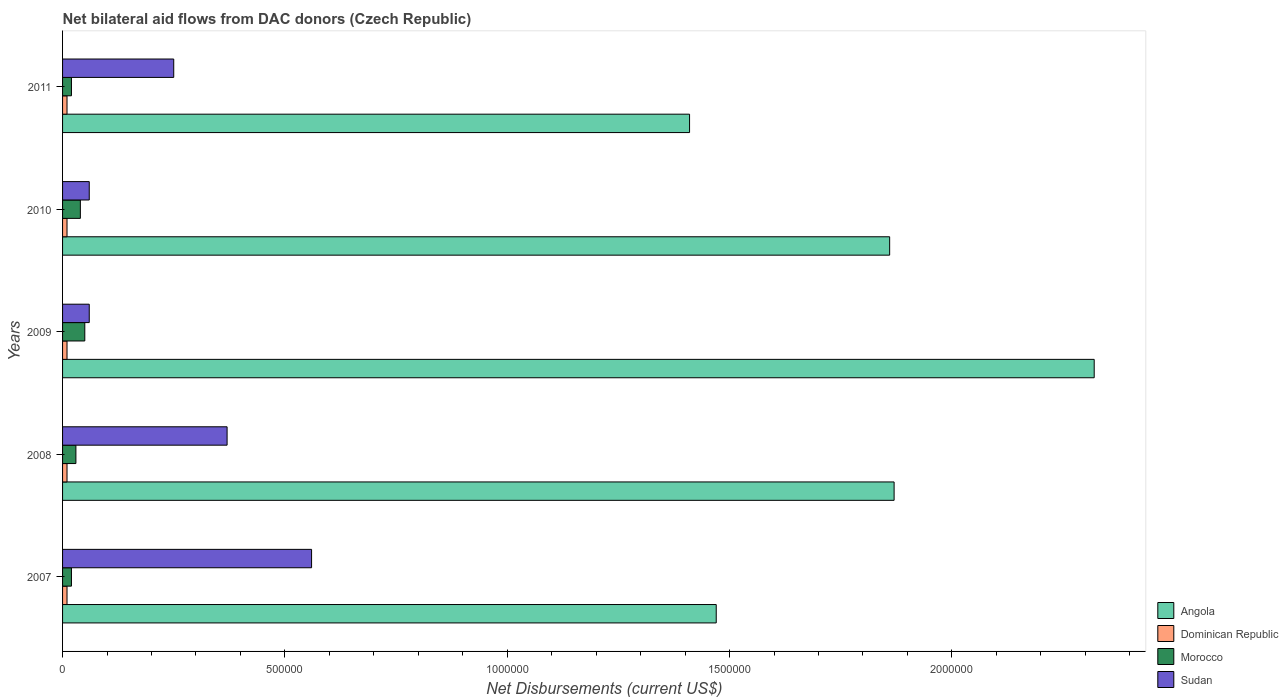How many different coloured bars are there?
Your response must be concise. 4. How many groups of bars are there?
Offer a very short reply. 5. Are the number of bars on each tick of the Y-axis equal?
Your answer should be compact. Yes. How many bars are there on the 1st tick from the bottom?
Offer a very short reply. 4. What is the label of the 3rd group of bars from the top?
Your answer should be very brief. 2009. In how many cases, is the number of bars for a given year not equal to the number of legend labels?
Make the answer very short. 0. What is the net bilateral aid flows in Angola in 2008?
Make the answer very short. 1.87e+06. Across all years, what is the maximum net bilateral aid flows in Sudan?
Your answer should be very brief. 5.60e+05. In which year was the net bilateral aid flows in Morocco minimum?
Offer a terse response. 2007. What is the total net bilateral aid flows in Angola in the graph?
Offer a very short reply. 8.93e+06. What is the difference between the net bilateral aid flows in Sudan in 2007 and that in 2009?
Make the answer very short. 5.00e+05. What is the difference between the net bilateral aid flows in Angola in 2009 and the net bilateral aid flows in Sudan in 2011?
Keep it short and to the point. 2.07e+06. What is the average net bilateral aid flows in Dominican Republic per year?
Offer a terse response. 10000. In the year 2007, what is the difference between the net bilateral aid flows in Dominican Republic and net bilateral aid flows in Sudan?
Provide a succinct answer. -5.50e+05. In how many years, is the net bilateral aid flows in Sudan greater than 200000 US$?
Make the answer very short. 3. What is the ratio of the net bilateral aid flows in Dominican Republic in 2009 to that in 2010?
Provide a succinct answer. 1. Is the net bilateral aid flows in Dominican Republic in 2008 less than that in 2009?
Your response must be concise. No. What is the difference between the highest and the second highest net bilateral aid flows in Morocco?
Your answer should be compact. 10000. What is the difference between the highest and the lowest net bilateral aid flows in Angola?
Make the answer very short. 9.10e+05. What does the 4th bar from the top in 2011 represents?
Provide a short and direct response. Angola. What does the 1st bar from the bottom in 2008 represents?
Provide a succinct answer. Angola. Is it the case that in every year, the sum of the net bilateral aid flows in Angola and net bilateral aid flows in Sudan is greater than the net bilateral aid flows in Dominican Republic?
Give a very brief answer. Yes. How many bars are there?
Give a very brief answer. 20. Are all the bars in the graph horizontal?
Give a very brief answer. Yes. Are the values on the major ticks of X-axis written in scientific E-notation?
Provide a succinct answer. No. Does the graph contain any zero values?
Your response must be concise. No. Where does the legend appear in the graph?
Make the answer very short. Bottom right. How are the legend labels stacked?
Your answer should be compact. Vertical. What is the title of the graph?
Your answer should be very brief. Net bilateral aid flows from DAC donors (Czech Republic). Does "Greece" appear as one of the legend labels in the graph?
Your answer should be very brief. No. What is the label or title of the X-axis?
Your answer should be very brief. Net Disbursements (current US$). What is the label or title of the Y-axis?
Offer a terse response. Years. What is the Net Disbursements (current US$) in Angola in 2007?
Your answer should be compact. 1.47e+06. What is the Net Disbursements (current US$) of Morocco in 2007?
Your answer should be compact. 2.00e+04. What is the Net Disbursements (current US$) in Sudan in 2007?
Your answer should be very brief. 5.60e+05. What is the Net Disbursements (current US$) in Angola in 2008?
Give a very brief answer. 1.87e+06. What is the Net Disbursements (current US$) of Dominican Republic in 2008?
Your response must be concise. 10000. What is the Net Disbursements (current US$) in Morocco in 2008?
Your answer should be compact. 3.00e+04. What is the Net Disbursements (current US$) in Angola in 2009?
Your response must be concise. 2.32e+06. What is the Net Disbursements (current US$) of Morocco in 2009?
Keep it short and to the point. 5.00e+04. What is the Net Disbursements (current US$) in Angola in 2010?
Ensure brevity in your answer.  1.86e+06. What is the Net Disbursements (current US$) of Dominican Republic in 2010?
Your response must be concise. 10000. What is the Net Disbursements (current US$) in Morocco in 2010?
Keep it short and to the point. 4.00e+04. What is the Net Disbursements (current US$) of Sudan in 2010?
Offer a very short reply. 6.00e+04. What is the Net Disbursements (current US$) in Angola in 2011?
Ensure brevity in your answer.  1.41e+06. What is the Net Disbursements (current US$) of Sudan in 2011?
Ensure brevity in your answer.  2.50e+05. Across all years, what is the maximum Net Disbursements (current US$) of Angola?
Make the answer very short. 2.32e+06. Across all years, what is the maximum Net Disbursements (current US$) of Dominican Republic?
Offer a terse response. 10000. Across all years, what is the maximum Net Disbursements (current US$) in Sudan?
Your answer should be very brief. 5.60e+05. Across all years, what is the minimum Net Disbursements (current US$) of Angola?
Offer a terse response. 1.41e+06. Across all years, what is the minimum Net Disbursements (current US$) of Dominican Republic?
Your response must be concise. 10000. Across all years, what is the minimum Net Disbursements (current US$) in Morocco?
Provide a succinct answer. 2.00e+04. Across all years, what is the minimum Net Disbursements (current US$) of Sudan?
Offer a terse response. 6.00e+04. What is the total Net Disbursements (current US$) of Angola in the graph?
Provide a short and direct response. 8.93e+06. What is the total Net Disbursements (current US$) of Sudan in the graph?
Provide a short and direct response. 1.30e+06. What is the difference between the Net Disbursements (current US$) in Angola in 2007 and that in 2008?
Give a very brief answer. -4.00e+05. What is the difference between the Net Disbursements (current US$) of Dominican Republic in 2007 and that in 2008?
Provide a succinct answer. 0. What is the difference between the Net Disbursements (current US$) of Sudan in 2007 and that in 2008?
Offer a very short reply. 1.90e+05. What is the difference between the Net Disbursements (current US$) in Angola in 2007 and that in 2009?
Provide a short and direct response. -8.50e+05. What is the difference between the Net Disbursements (current US$) in Sudan in 2007 and that in 2009?
Your answer should be very brief. 5.00e+05. What is the difference between the Net Disbursements (current US$) in Angola in 2007 and that in 2010?
Ensure brevity in your answer.  -3.90e+05. What is the difference between the Net Disbursements (current US$) of Dominican Republic in 2007 and that in 2010?
Your answer should be very brief. 0. What is the difference between the Net Disbursements (current US$) in Morocco in 2007 and that in 2010?
Provide a succinct answer. -2.00e+04. What is the difference between the Net Disbursements (current US$) of Sudan in 2007 and that in 2010?
Keep it short and to the point. 5.00e+05. What is the difference between the Net Disbursements (current US$) in Morocco in 2007 and that in 2011?
Provide a succinct answer. 0. What is the difference between the Net Disbursements (current US$) of Sudan in 2007 and that in 2011?
Make the answer very short. 3.10e+05. What is the difference between the Net Disbursements (current US$) in Angola in 2008 and that in 2009?
Provide a short and direct response. -4.50e+05. What is the difference between the Net Disbursements (current US$) in Morocco in 2008 and that in 2009?
Offer a very short reply. -2.00e+04. What is the difference between the Net Disbursements (current US$) of Morocco in 2009 and that in 2010?
Provide a short and direct response. 10000. What is the difference between the Net Disbursements (current US$) of Sudan in 2009 and that in 2010?
Provide a short and direct response. 0. What is the difference between the Net Disbursements (current US$) of Angola in 2009 and that in 2011?
Offer a terse response. 9.10e+05. What is the difference between the Net Disbursements (current US$) in Dominican Republic in 2009 and that in 2011?
Offer a very short reply. 0. What is the difference between the Net Disbursements (current US$) of Dominican Republic in 2010 and that in 2011?
Your answer should be compact. 0. What is the difference between the Net Disbursements (current US$) of Morocco in 2010 and that in 2011?
Keep it short and to the point. 2.00e+04. What is the difference between the Net Disbursements (current US$) of Sudan in 2010 and that in 2011?
Give a very brief answer. -1.90e+05. What is the difference between the Net Disbursements (current US$) in Angola in 2007 and the Net Disbursements (current US$) in Dominican Republic in 2008?
Keep it short and to the point. 1.46e+06. What is the difference between the Net Disbursements (current US$) in Angola in 2007 and the Net Disbursements (current US$) in Morocco in 2008?
Offer a very short reply. 1.44e+06. What is the difference between the Net Disbursements (current US$) in Angola in 2007 and the Net Disbursements (current US$) in Sudan in 2008?
Make the answer very short. 1.10e+06. What is the difference between the Net Disbursements (current US$) of Dominican Republic in 2007 and the Net Disbursements (current US$) of Sudan in 2008?
Your answer should be very brief. -3.60e+05. What is the difference between the Net Disbursements (current US$) in Morocco in 2007 and the Net Disbursements (current US$) in Sudan in 2008?
Your response must be concise. -3.50e+05. What is the difference between the Net Disbursements (current US$) of Angola in 2007 and the Net Disbursements (current US$) of Dominican Republic in 2009?
Provide a succinct answer. 1.46e+06. What is the difference between the Net Disbursements (current US$) of Angola in 2007 and the Net Disbursements (current US$) of Morocco in 2009?
Offer a terse response. 1.42e+06. What is the difference between the Net Disbursements (current US$) in Angola in 2007 and the Net Disbursements (current US$) in Sudan in 2009?
Offer a very short reply. 1.41e+06. What is the difference between the Net Disbursements (current US$) of Dominican Republic in 2007 and the Net Disbursements (current US$) of Sudan in 2009?
Make the answer very short. -5.00e+04. What is the difference between the Net Disbursements (current US$) of Angola in 2007 and the Net Disbursements (current US$) of Dominican Republic in 2010?
Provide a short and direct response. 1.46e+06. What is the difference between the Net Disbursements (current US$) of Angola in 2007 and the Net Disbursements (current US$) of Morocco in 2010?
Provide a succinct answer. 1.43e+06. What is the difference between the Net Disbursements (current US$) of Angola in 2007 and the Net Disbursements (current US$) of Sudan in 2010?
Provide a succinct answer. 1.41e+06. What is the difference between the Net Disbursements (current US$) in Angola in 2007 and the Net Disbursements (current US$) in Dominican Republic in 2011?
Make the answer very short. 1.46e+06. What is the difference between the Net Disbursements (current US$) in Angola in 2007 and the Net Disbursements (current US$) in Morocco in 2011?
Ensure brevity in your answer.  1.45e+06. What is the difference between the Net Disbursements (current US$) of Angola in 2007 and the Net Disbursements (current US$) of Sudan in 2011?
Give a very brief answer. 1.22e+06. What is the difference between the Net Disbursements (current US$) of Dominican Republic in 2007 and the Net Disbursements (current US$) of Morocco in 2011?
Give a very brief answer. -10000. What is the difference between the Net Disbursements (current US$) of Angola in 2008 and the Net Disbursements (current US$) of Dominican Republic in 2009?
Your answer should be very brief. 1.86e+06. What is the difference between the Net Disbursements (current US$) of Angola in 2008 and the Net Disbursements (current US$) of Morocco in 2009?
Your response must be concise. 1.82e+06. What is the difference between the Net Disbursements (current US$) of Angola in 2008 and the Net Disbursements (current US$) of Sudan in 2009?
Keep it short and to the point. 1.81e+06. What is the difference between the Net Disbursements (current US$) of Angola in 2008 and the Net Disbursements (current US$) of Dominican Republic in 2010?
Provide a succinct answer. 1.86e+06. What is the difference between the Net Disbursements (current US$) in Angola in 2008 and the Net Disbursements (current US$) in Morocco in 2010?
Your answer should be very brief. 1.83e+06. What is the difference between the Net Disbursements (current US$) of Angola in 2008 and the Net Disbursements (current US$) of Sudan in 2010?
Your response must be concise. 1.81e+06. What is the difference between the Net Disbursements (current US$) of Morocco in 2008 and the Net Disbursements (current US$) of Sudan in 2010?
Provide a short and direct response. -3.00e+04. What is the difference between the Net Disbursements (current US$) of Angola in 2008 and the Net Disbursements (current US$) of Dominican Republic in 2011?
Your answer should be compact. 1.86e+06. What is the difference between the Net Disbursements (current US$) of Angola in 2008 and the Net Disbursements (current US$) of Morocco in 2011?
Make the answer very short. 1.85e+06. What is the difference between the Net Disbursements (current US$) of Angola in 2008 and the Net Disbursements (current US$) of Sudan in 2011?
Offer a very short reply. 1.62e+06. What is the difference between the Net Disbursements (current US$) of Dominican Republic in 2008 and the Net Disbursements (current US$) of Morocco in 2011?
Provide a short and direct response. -10000. What is the difference between the Net Disbursements (current US$) of Angola in 2009 and the Net Disbursements (current US$) of Dominican Republic in 2010?
Ensure brevity in your answer.  2.31e+06. What is the difference between the Net Disbursements (current US$) in Angola in 2009 and the Net Disbursements (current US$) in Morocco in 2010?
Ensure brevity in your answer.  2.28e+06. What is the difference between the Net Disbursements (current US$) of Angola in 2009 and the Net Disbursements (current US$) of Sudan in 2010?
Your answer should be very brief. 2.26e+06. What is the difference between the Net Disbursements (current US$) of Dominican Republic in 2009 and the Net Disbursements (current US$) of Morocco in 2010?
Your answer should be compact. -3.00e+04. What is the difference between the Net Disbursements (current US$) of Angola in 2009 and the Net Disbursements (current US$) of Dominican Republic in 2011?
Offer a terse response. 2.31e+06. What is the difference between the Net Disbursements (current US$) of Angola in 2009 and the Net Disbursements (current US$) of Morocco in 2011?
Give a very brief answer. 2.30e+06. What is the difference between the Net Disbursements (current US$) of Angola in 2009 and the Net Disbursements (current US$) of Sudan in 2011?
Make the answer very short. 2.07e+06. What is the difference between the Net Disbursements (current US$) in Dominican Republic in 2009 and the Net Disbursements (current US$) in Sudan in 2011?
Make the answer very short. -2.40e+05. What is the difference between the Net Disbursements (current US$) of Morocco in 2009 and the Net Disbursements (current US$) of Sudan in 2011?
Give a very brief answer. -2.00e+05. What is the difference between the Net Disbursements (current US$) in Angola in 2010 and the Net Disbursements (current US$) in Dominican Republic in 2011?
Ensure brevity in your answer.  1.85e+06. What is the difference between the Net Disbursements (current US$) of Angola in 2010 and the Net Disbursements (current US$) of Morocco in 2011?
Provide a succinct answer. 1.84e+06. What is the difference between the Net Disbursements (current US$) in Angola in 2010 and the Net Disbursements (current US$) in Sudan in 2011?
Your answer should be very brief. 1.61e+06. What is the difference between the Net Disbursements (current US$) in Morocco in 2010 and the Net Disbursements (current US$) in Sudan in 2011?
Give a very brief answer. -2.10e+05. What is the average Net Disbursements (current US$) of Angola per year?
Provide a succinct answer. 1.79e+06. What is the average Net Disbursements (current US$) of Dominican Republic per year?
Ensure brevity in your answer.  10000. What is the average Net Disbursements (current US$) of Morocco per year?
Your answer should be compact. 3.20e+04. In the year 2007, what is the difference between the Net Disbursements (current US$) of Angola and Net Disbursements (current US$) of Dominican Republic?
Your answer should be compact. 1.46e+06. In the year 2007, what is the difference between the Net Disbursements (current US$) of Angola and Net Disbursements (current US$) of Morocco?
Offer a terse response. 1.45e+06. In the year 2007, what is the difference between the Net Disbursements (current US$) in Angola and Net Disbursements (current US$) in Sudan?
Your answer should be very brief. 9.10e+05. In the year 2007, what is the difference between the Net Disbursements (current US$) in Dominican Republic and Net Disbursements (current US$) in Sudan?
Offer a very short reply. -5.50e+05. In the year 2007, what is the difference between the Net Disbursements (current US$) of Morocco and Net Disbursements (current US$) of Sudan?
Your answer should be compact. -5.40e+05. In the year 2008, what is the difference between the Net Disbursements (current US$) in Angola and Net Disbursements (current US$) in Dominican Republic?
Your answer should be compact. 1.86e+06. In the year 2008, what is the difference between the Net Disbursements (current US$) of Angola and Net Disbursements (current US$) of Morocco?
Your answer should be very brief. 1.84e+06. In the year 2008, what is the difference between the Net Disbursements (current US$) of Angola and Net Disbursements (current US$) of Sudan?
Make the answer very short. 1.50e+06. In the year 2008, what is the difference between the Net Disbursements (current US$) of Dominican Republic and Net Disbursements (current US$) of Sudan?
Provide a succinct answer. -3.60e+05. In the year 2008, what is the difference between the Net Disbursements (current US$) of Morocco and Net Disbursements (current US$) of Sudan?
Offer a very short reply. -3.40e+05. In the year 2009, what is the difference between the Net Disbursements (current US$) of Angola and Net Disbursements (current US$) of Dominican Republic?
Make the answer very short. 2.31e+06. In the year 2009, what is the difference between the Net Disbursements (current US$) of Angola and Net Disbursements (current US$) of Morocco?
Your answer should be compact. 2.27e+06. In the year 2009, what is the difference between the Net Disbursements (current US$) of Angola and Net Disbursements (current US$) of Sudan?
Give a very brief answer. 2.26e+06. In the year 2009, what is the difference between the Net Disbursements (current US$) of Dominican Republic and Net Disbursements (current US$) of Sudan?
Your response must be concise. -5.00e+04. In the year 2010, what is the difference between the Net Disbursements (current US$) of Angola and Net Disbursements (current US$) of Dominican Republic?
Offer a terse response. 1.85e+06. In the year 2010, what is the difference between the Net Disbursements (current US$) in Angola and Net Disbursements (current US$) in Morocco?
Keep it short and to the point. 1.82e+06. In the year 2010, what is the difference between the Net Disbursements (current US$) in Angola and Net Disbursements (current US$) in Sudan?
Your answer should be very brief. 1.80e+06. In the year 2010, what is the difference between the Net Disbursements (current US$) of Dominican Republic and Net Disbursements (current US$) of Morocco?
Provide a succinct answer. -3.00e+04. In the year 2010, what is the difference between the Net Disbursements (current US$) in Morocco and Net Disbursements (current US$) in Sudan?
Your answer should be compact. -2.00e+04. In the year 2011, what is the difference between the Net Disbursements (current US$) in Angola and Net Disbursements (current US$) in Dominican Republic?
Provide a succinct answer. 1.40e+06. In the year 2011, what is the difference between the Net Disbursements (current US$) in Angola and Net Disbursements (current US$) in Morocco?
Offer a terse response. 1.39e+06. In the year 2011, what is the difference between the Net Disbursements (current US$) of Angola and Net Disbursements (current US$) of Sudan?
Your answer should be compact. 1.16e+06. In the year 2011, what is the difference between the Net Disbursements (current US$) of Dominican Republic and Net Disbursements (current US$) of Morocco?
Your response must be concise. -10000. In the year 2011, what is the difference between the Net Disbursements (current US$) in Morocco and Net Disbursements (current US$) in Sudan?
Keep it short and to the point. -2.30e+05. What is the ratio of the Net Disbursements (current US$) in Angola in 2007 to that in 2008?
Offer a terse response. 0.79. What is the ratio of the Net Disbursements (current US$) of Morocco in 2007 to that in 2008?
Offer a very short reply. 0.67. What is the ratio of the Net Disbursements (current US$) of Sudan in 2007 to that in 2008?
Offer a very short reply. 1.51. What is the ratio of the Net Disbursements (current US$) in Angola in 2007 to that in 2009?
Your answer should be very brief. 0.63. What is the ratio of the Net Disbursements (current US$) of Dominican Republic in 2007 to that in 2009?
Offer a very short reply. 1. What is the ratio of the Net Disbursements (current US$) in Sudan in 2007 to that in 2009?
Your answer should be very brief. 9.33. What is the ratio of the Net Disbursements (current US$) in Angola in 2007 to that in 2010?
Ensure brevity in your answer.  0.79. What is the ratio of the Net Disbursements (current US$) in Dominican Republic in 2007 to that in 2010?
Keep it short and to the point. 1. What is the ratio of the Net Disbursements (current US$) in Morocco in 2007 to that in 2010?
Offer a very short reply. 0.5. What is the ratio of the Net Disbursements (current US$) in Sudan in 2007 to that in 2010?
Provide a short and direct response. 9.33. What is the ratio of the Net Disbursements (current US$) in Angola in 2007 to that in 2011?
Your answer should be compact. 1.04. What is the ratio of the Net Disbursements (current US$) of Morocco in 2007 to that in 2011?
Your answer should be compact. 1. What is the ratio of the Net Disbursements (current US$) of Sudan in 2007 to that in 2011?
Your answer should be very brief. 2.24. What is the ratio of the Net Disbursements (current US$) of Angola in 2008 to that in 2009?
Your answer should be compact. 0.81. What is the ratio of the Net Disbursements (current US$) in Morocco in 2008 to that in 2009?
Ensure brevity in your answer.  0.6. What is the ratio of the Net Disbursements (current US$) of Sudan in 2008 to that in 2009?
Your answer should be very brief. 6.17. What is the ratio of the Net Disbursements (current US$) of Angola in 2008 to that in 2010?
Your answer should be compact. 1.01. What is the ratio of the Net Disbursements (current US$) in Dominican Republic in 2008 to that in 2010?
Keep it short and to the point. 1. What is the ratio of the Net Disbursements (current US$) of Morocco in 2008 to that in 2010?
Keep it short and to the point. 0.75. What is the ratio of the Net Disbursements (current US$) of Sudan in 2008 to that in 2010?
Your response must be concise. 6.17. What is the ratio of the Net Disbursements (current US$) of Angola in 2008 to that in 2011?
Make the answer very short. 1.33. What is the ratio of the Net Disbursements (current US$) of Sudan in 2008 to that in 2011?
Your response must be concise. 1.48. What is the ratio of the Net Disbursements (current US$) of Angola in 2009 to that in 2010?
Offer a terse response. 1.25. What is the ratio of the Net Disbursements (current US$) of Dominican Republic in 2009 to that in 2010?
Give a very brief answer. 1. What is the ratio of the Net Disbursements (current US$) in Morocco in 2009 to that in 2010?
Ensure brevity in your answer.  1.25. What is the ratio of the Net Disbursements (current US$) in Angola in 2009 to that in 2011?
Ensure brevity in your answer.  1.65. What is the ratio of the Net Disbursements (current US$) of Sudan in 2009 to that in 2011?
Offer a terse response. 0.24. What is the ratio of the Net Disbursements (current US$) of Angola in 2010 to that in 2011?
Your answer should be very brief. 1.32. What is the ratio of the Net Disbursements (current US$) in Dominican Republic in 2010 to that in 2011?
Provide a short and direct response. 1. What is the ratio of the Net Disbursements (current US$) of Morocco in 2010 to that in 2011?
Offer a terse response. 2. What is the ratio of the Net Disbursements (current US$) in Sudan in 2010 to that in 2011?
Ensure brevity in your answer.  0.24. What is the difference between the highest and the lowest Net Disbursements (current US$) of Angola?
Offer a very short reply. 9.10e+05. What is the difference between the highest and the lowest Net Disbursements (current US$) in Sudan?
Offer a terse response. 5.00e+05. 